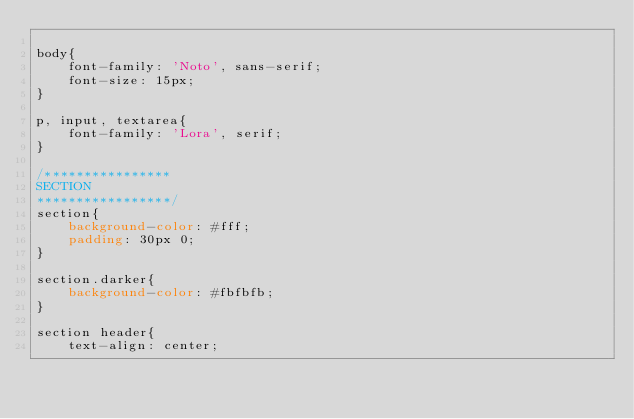Convert code to text. <code><loc_0><loc_0><loc_500><loc_500><_CSS_>
body{
	font-family: 'Noto', sans-serif;
	font-size: 15px;
}

p, input, textarea{
	font-family: 'Lora', serif;
}

/****************
SECTION
*****************/
section{
	background-color: #fff;
	padding: 30px 0;
}

section.darker{
	background-color: #fbfbfb;
}

section header{
	text-align: center;</code> 